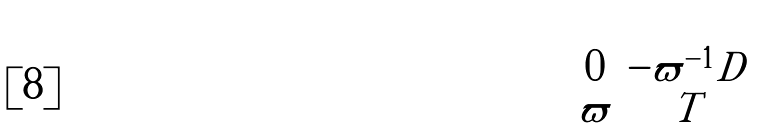<formula> <loc_0><loc_0><loc_500><loc_500>\begin{pmatrix} 0 & - \varpi ^ { - 1 } D \\ \varpi & T \end{pmatrix}</formula> 